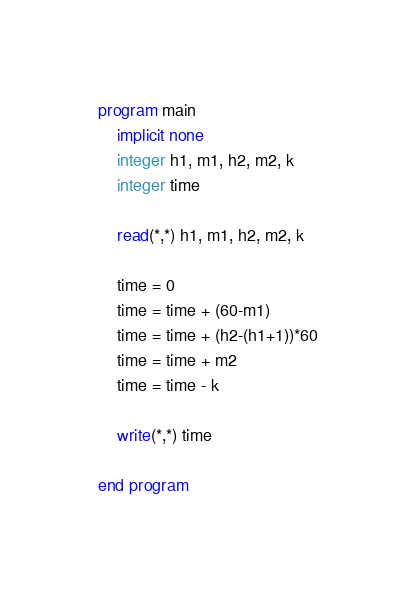Convert code to text. <code><loc_0><loc_0><loc_500><loc_500><_FORTRAN_>program main
    implicit none
    integer h1, m1, h2, m2, k
    integer time

    read(*,*) h1, m1, h2, m2, k

    time = 0
    time = time + (60-m1)
    time = time + (h2-(h1+1))*60
    time = time + m2
    time = time - k

    write(*,*) time

end program

</code> 